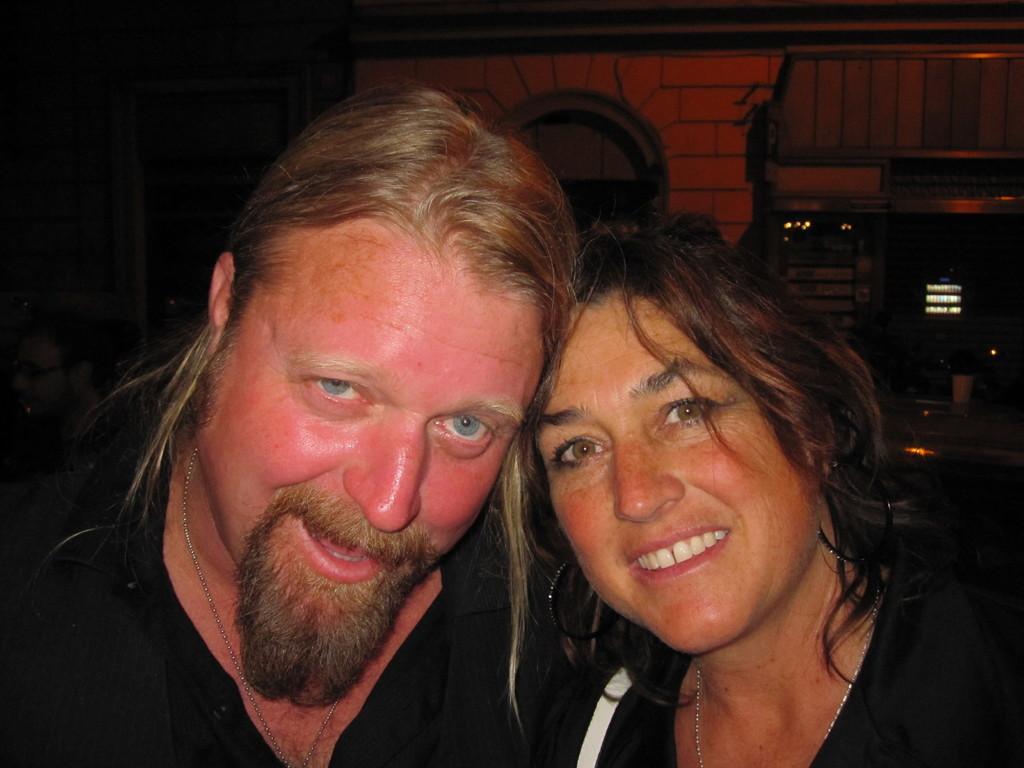In one or two sentences, can you explain what this image depicts? In the image I can see a lady and a guy in black dress and behind there are some other things. 